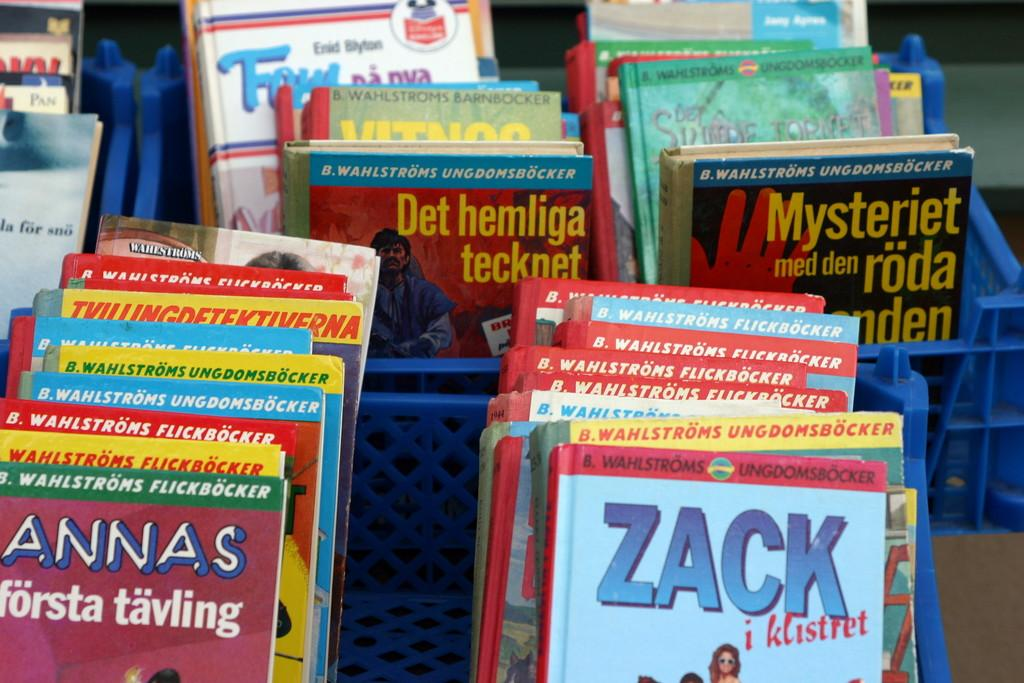Provide a one-sentence caption for the provided image. Some kids books are on the rack and one of the book is about a person named Zack. 